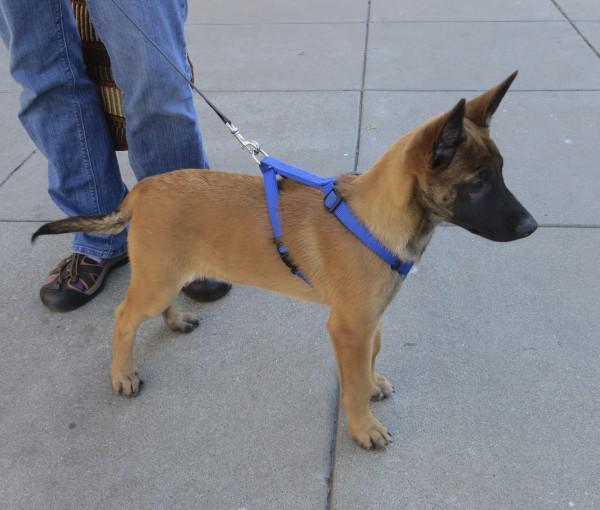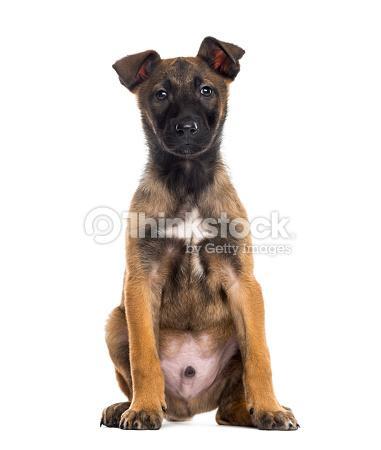The first image is the image on the left, the second image is the image on the right. For the images shown, is this caption "The dog in the image on the left is wearing a leash." true? Answer yes or no. Yes. The first image is the image on the left, the second image is the image on the right. Analyze the images presented: Is the assertion "A dog is standing on all fours on a hard surface and wears a leash." valid? Answer yes or no. Yes. 